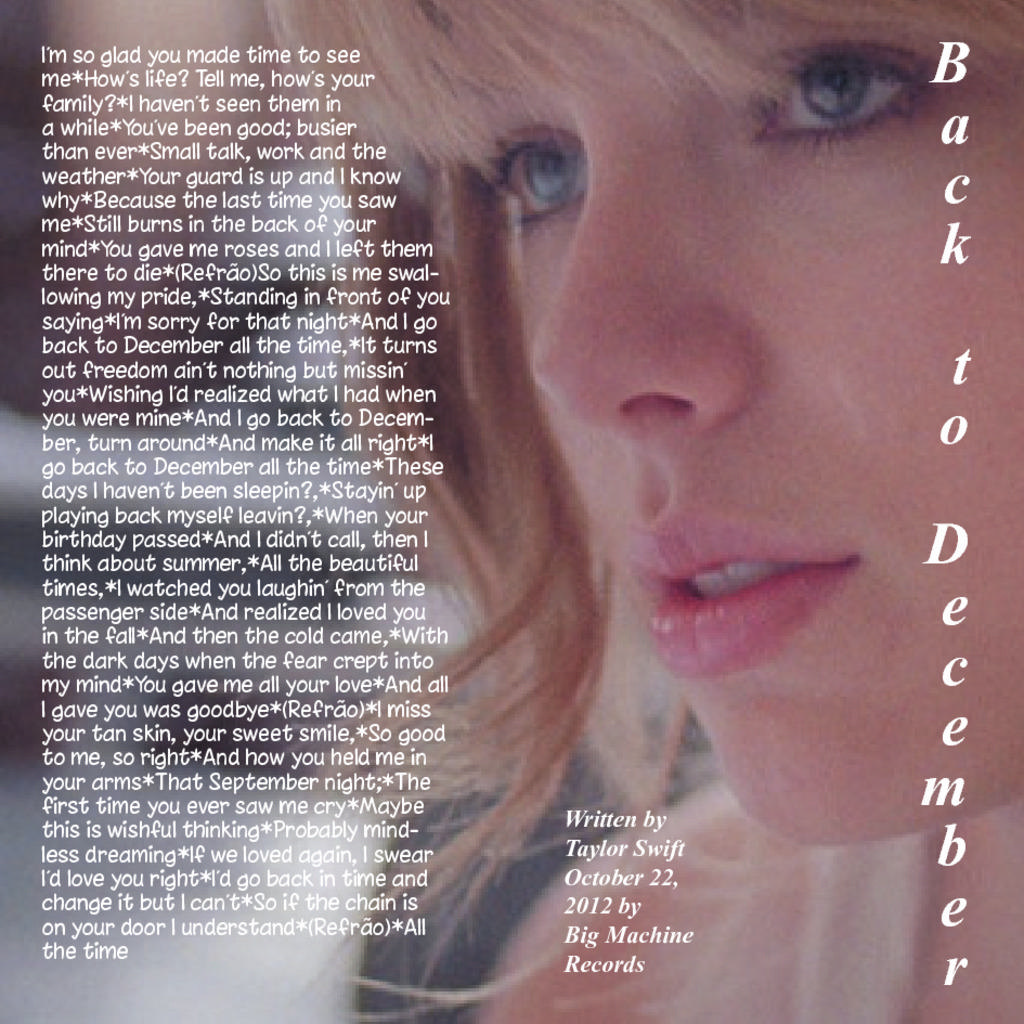What is the main subject of the image? There is a girl's face in the image. How would you describe the background of the image? The background of the image is blurry. Are there any words or letters visible in the image? Yes, there is some text visible in the image. What type of cap is the girl wearing in the image? There is no cap visible in the image; only the girl's face is shown. How many bottles can be seen in the image? There are no bottles present in the image. 